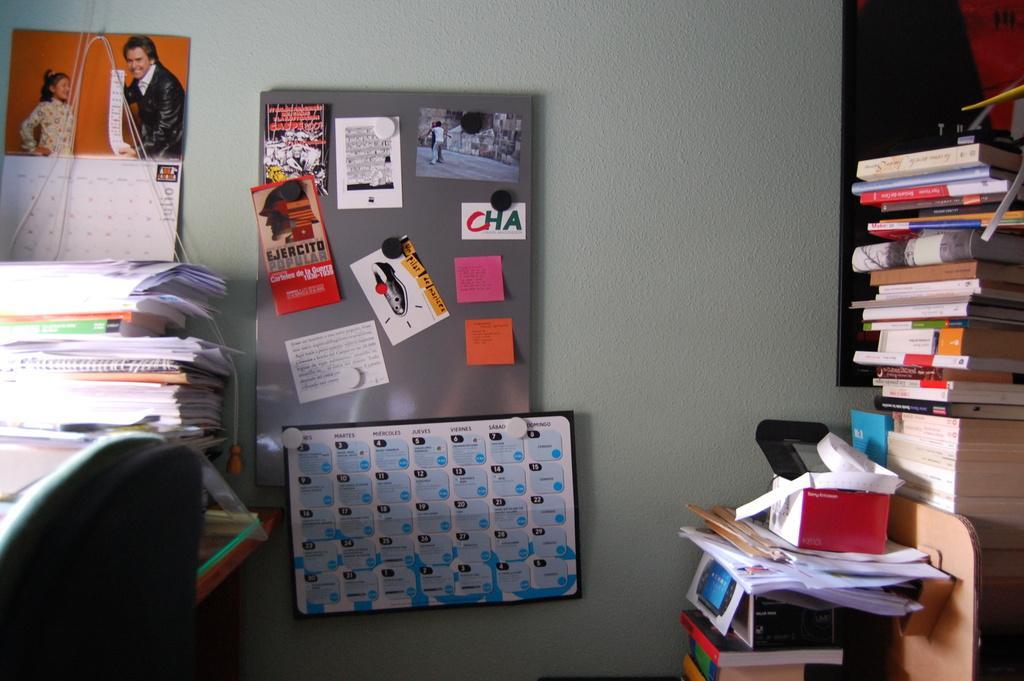Describe this image in one or two sentences. This picture is clicked inside the room. On the right side, we see books which are placed on the table. Beside that, we see books and papers. On the right side, we see a table on which books, papers and files are placed. Beside that, we see a chair. In the background, we see a white wall on which two calendars and a grey color board with posters pasted on it are placed. 